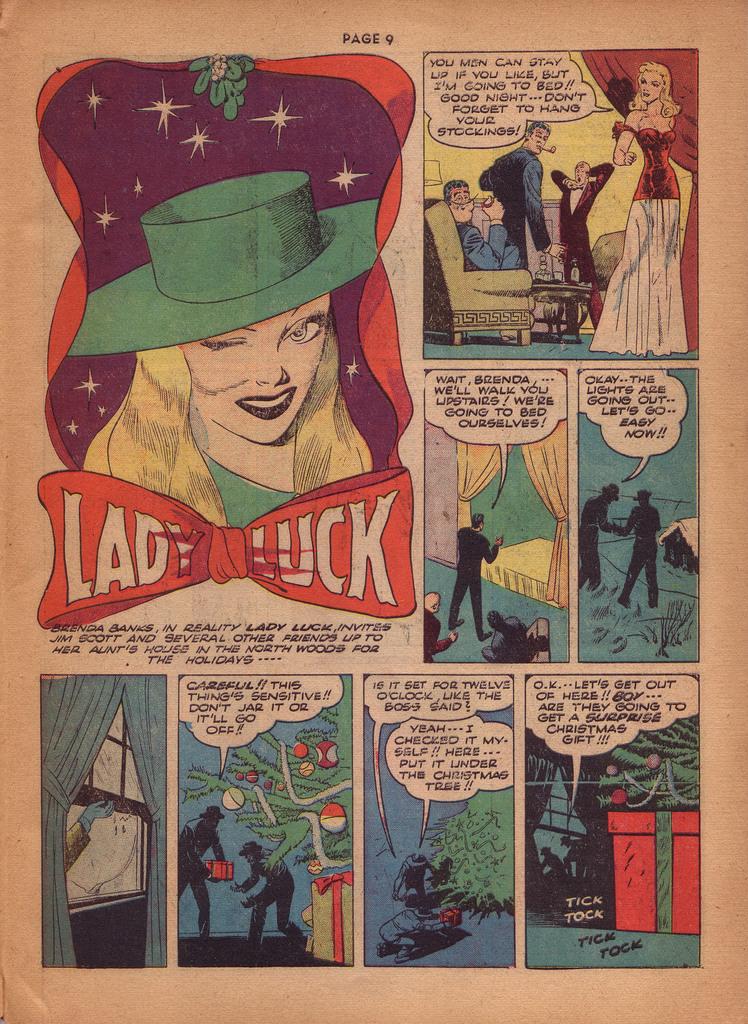What is the name of the comic?
Offer a very short reply. Lady luck. Which page was this printed on?
Keep it short and to the point. 9. 